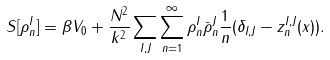Convert formula to latex. <formula><loc_0><loc_0><loc_500><loc_500>S [ \rho ^ { I } _ { n } ] = \beta V _ { 0 } + \frac { N ^ { 2 } } { k ^ { 2 } } \sum _ { I , J } \sum _ { n = 1 } ^ { \infty } \rho ^ { I } _ { n } \bar { \rho } ^ { J } _ { n } \frac { 1 } { n } ( \delta _ { I , J } - z ^ { I , J } _ { n } ( x ) ) .</formula> 